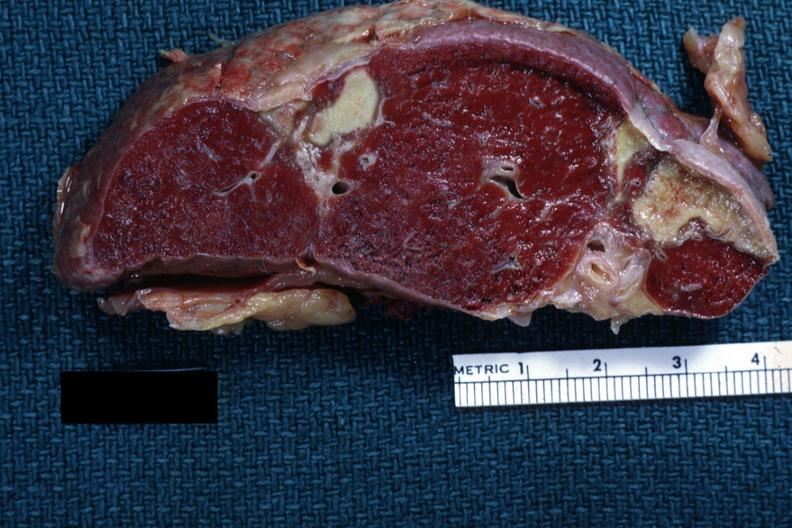s spleen present?
Answer the question using a single word or phrase. Yes 